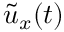Convert formula to latex. <formula><loc_0><loc_0><loc_500><loc_500>\tilde { u } _ { x } ( t )</formula> 